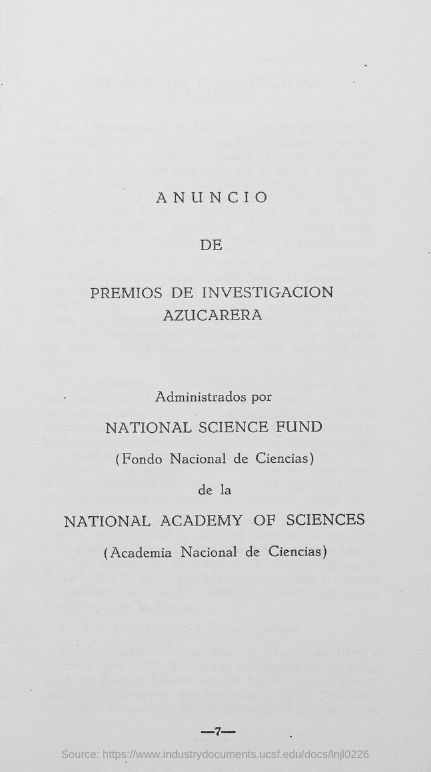Mention a couple of crucial points in this snapshot. The Page Number is -7- and below. 